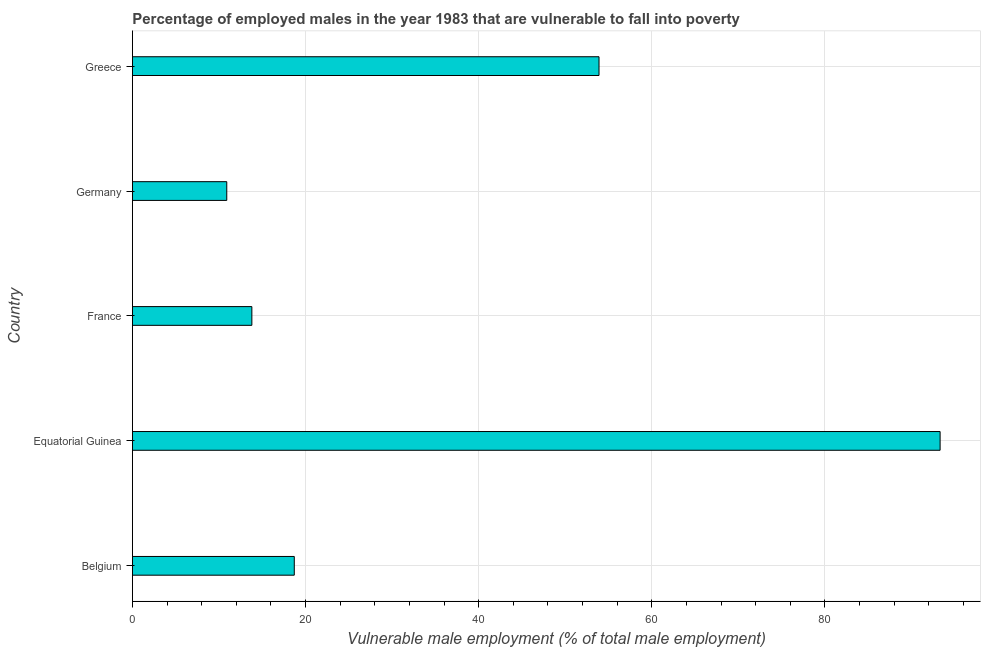Does the graph contain grids?
Provide a succinct answer. Yes. What is the title of the graph?
Provide a succinct answer. Percentage of employed males in the year 1983 that are vulnerable to fall into poverty. What is the label or title of the X-axis?
Keep it short and to the point. Vulnerable male employment (% of total male employment). What is the label or title of the Y-axis?
Your answer should be compact. Country. What is the percentage of employed males who are vulnerable to fall into poverty in France?
Provide a succinct answer. 13.8. Across all countries, what is the maximum percentage of employed males who are vulnerable to fall into poverty?
Ensure brevity in your answer.  93.3. Across all countries, what is the minimum percentage of employed males who are vulnerable to fall into poverty?
Offer a very short reply. 10.9. In which country was the percentage of employed males who are vulnerable to fall into poverty maximum?
Your answer should be compact. Equatorial Guinea. What is the sum of the percentage of employed males who are vulnerable to fall into poverty?
Give a very brief answer. 190.6. What is the difference between the percentage of employed males who are vulnerable to fall into poverty in Belgium and Greece?
Your answer should be very brief. -35.2. What is the average percentage of employed males who are vulnerable to fall into poverty per country?
Give a very brief answer. 38.12. What is the median percentage of employed males who are vulnerable to fall into poverty?
Offer a very short reply. 18.7. What is the ratio of the percentage of employed males who are vulnerable to fall into poverty in France to that in Germany?
Offer a very short reply. 1.27. Is the percentage of employed males who are vulnerable to fall into poverty in Belgium less than that in Germany?
Your response must be concise. No. What is the difference between the highest and the second highest percentage of employed males who are vulnerable to fall into poverty?
Your response must be concise. 39.4. What is the difference between the highest and the lowest percentage of employed males who are vulnerable to fall into poverty?
Provide a succinct answer. 82.4. In how many countries, is the percentage of employed males who are vulnerable to fall into poverty greater than the average percentage of employed males who are vulnerable to fall into poverty taken over all countries?
Provide a succinct answer. 2. Are all the bars in the graph horizontal?
Offer a very short reply. Yes. What is the Vulnerable male employment (% of total male employment) of Belgium?
Make the answer very short. 18.7. What is the Vulnerable male employment (% of total male employment) in Equatorial Guinea?
Provide a short and direct response. 93.3. What is the Vulnerable male employment (% of total male employment) in France?
Offer a very short reply. 13.8. What is the Vulnerable male employment (% of total male employment) in Germany?
Make the answer very short. 10.9. What is the Vulnerable male employment (% of total male employment) in Greece?
Your answer should be very brief. 53.9. What is the difference between the Vulnerable male employment (% of total male employment) in Belgium and Equatorial Guinea?
Your response must be concise. -74.6. What is the difference between the Vulnerable male employment (% of total male employment) in Belgium and France?
Your answer should be very brief. 4.9. What is the difference between the Vulnerable male employment (% of total male employment) in Belgium and Germany?
Your answer should be compact. 7.8. What is the difference between the Vulnerable male employment (% of total male employment) in Belgium and Greece?
Ensure brevity in your answer.  -35.2. What is the difference between the Vulnerable male employment (% of total male employment) in Equatorial Guinea and France?
Ensure brevity in your answer.  79.5. What is the difference between the Vulnerable male employment (% of total male employment) in Equatorial Guinea and Germany?
Ensure brevity in your answer.  82.4. What is the difference between the Vulnerable male employment (% of total male employment) in Equatorial Guinea and Greece?
Offer a very short reply. 39.4. What is the difference between the Vulnerable male employment (% of total male employment) in France and Greece?
Make the answer very short. -40.1. What is the difference between the Vulnerable male employment (% of total male employment) in Germany and Greece?
Offer a terse response. -43. What is the ratio of the Vulnerable male employment (% of total male employment) in Belgium to that in Equatorial Guinea?
Your answer should be compact. 0.2. What is the ratio of the Vulnerable male employment (% of total male employment) in Belgium to that in France?
Your answer should be compact. 1.35. What is the ratio of the Vulnerable male employment (% of total male employment) in Belgium to that in Germany?
Give a very brief answer. 1.72. What is the ratio of the Vulnerable male employment (% of total male employment) in Belgium to that in Greece?
Offer a very short reply. 0.35. What is the ratio of the Vulnerable male employment (% of total male employment) in Equatorial Guinea to that in France?
Ensure brevity in your answer.  6.76. What is the ratio of the Vulnerable male employment (% of total male employment) in Equatorial Guinea to that in Germany?
Make the answer very short. 8.56. What is the ratio of the Vulnerable male employment (% of total male employment) in Equatorial Guinea to that in Greece?
Give a very brief answer. 1.73. What is the ratio of the Vulnerable male employment (% of total male employment) in France to that in Germany?
Ensure brevity in your answer.  1.27. What is the ratio of the Vulnerable male employment (% of total male employment) in France to that in Greece?
Ensure brevity in your answer.  0.26. What is the ratio of the Vulnerable male employment (% of total male employment) in Germany to that in Greece?
Your response must be concise. 0.2. 